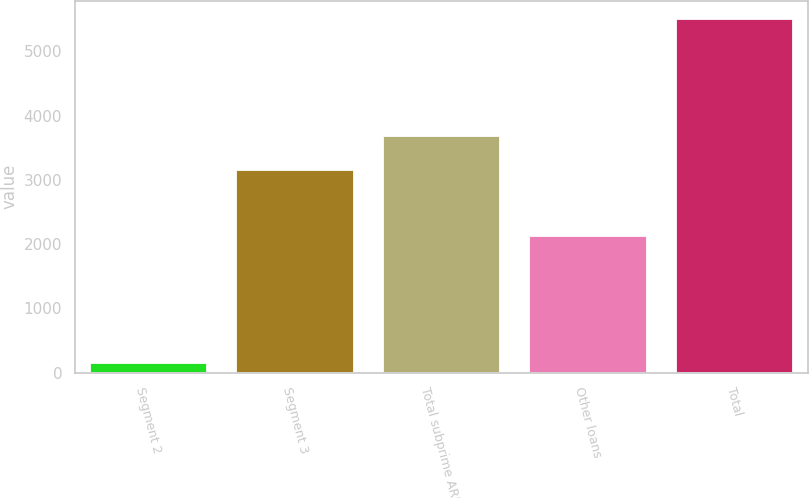Convert chart to OTSL. <chart><loc_0><loc_0><loc_500><loc_500><bar_chart><fcel>Segment 2<fcel>Segment 3<fcel>Total subprime ARMs<fcel>Other loans<fcel>Total<nl><fcel>155<fcel>3150<fcel>3685.4<fcel>2126<fcel>5509<nl></chart> 